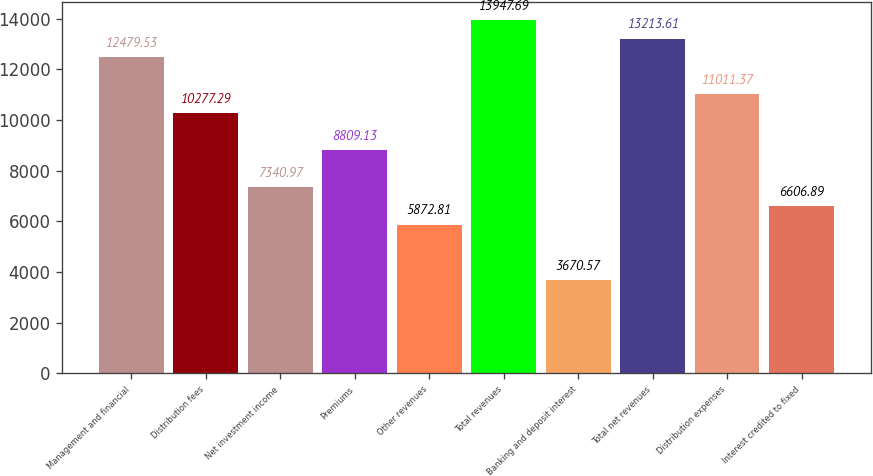<chart> <loc_0><loc_0><loc_500><loc_500><bar_chart><fcel>Management and financial<fcel>Distribution fees<fcel>Net investment income<fcel>Premiums<fcel>Other revenues<fcel>Total revenues<fcel>Banking and deposit interest<fcel>Total net revenues<fcel>Distribution expenses<fcel>Interest credited to fixed<nl><fcel>12479.5<fcel>10277.3<fcel>7340.97<fcel>8809.13<fcel>5872.81<fcel>13947.7<fcel>3670.57<fcel>13213.6<fcel>11011.4<fcel>6606.89<nl></chart> 